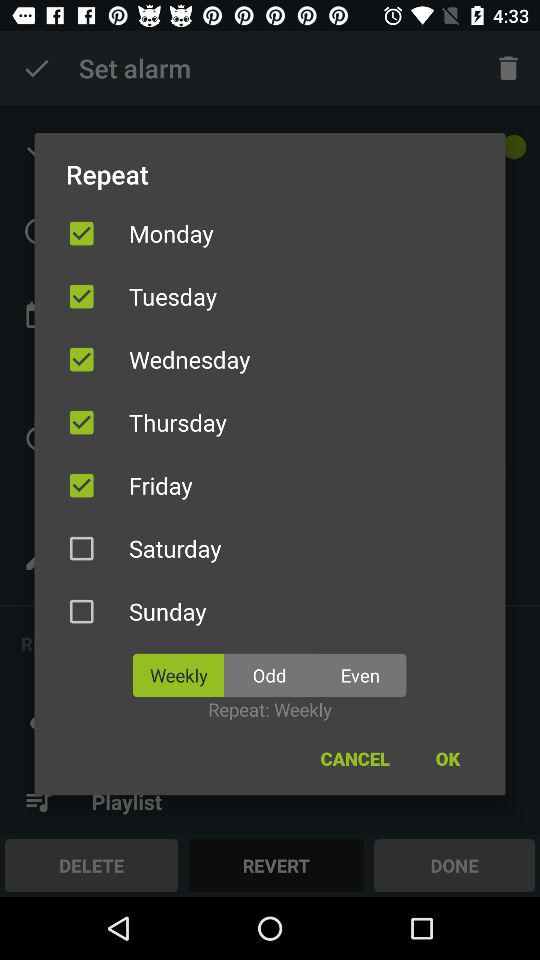How many days are weekdays?
Answer the question using a single word or phrase. 5 